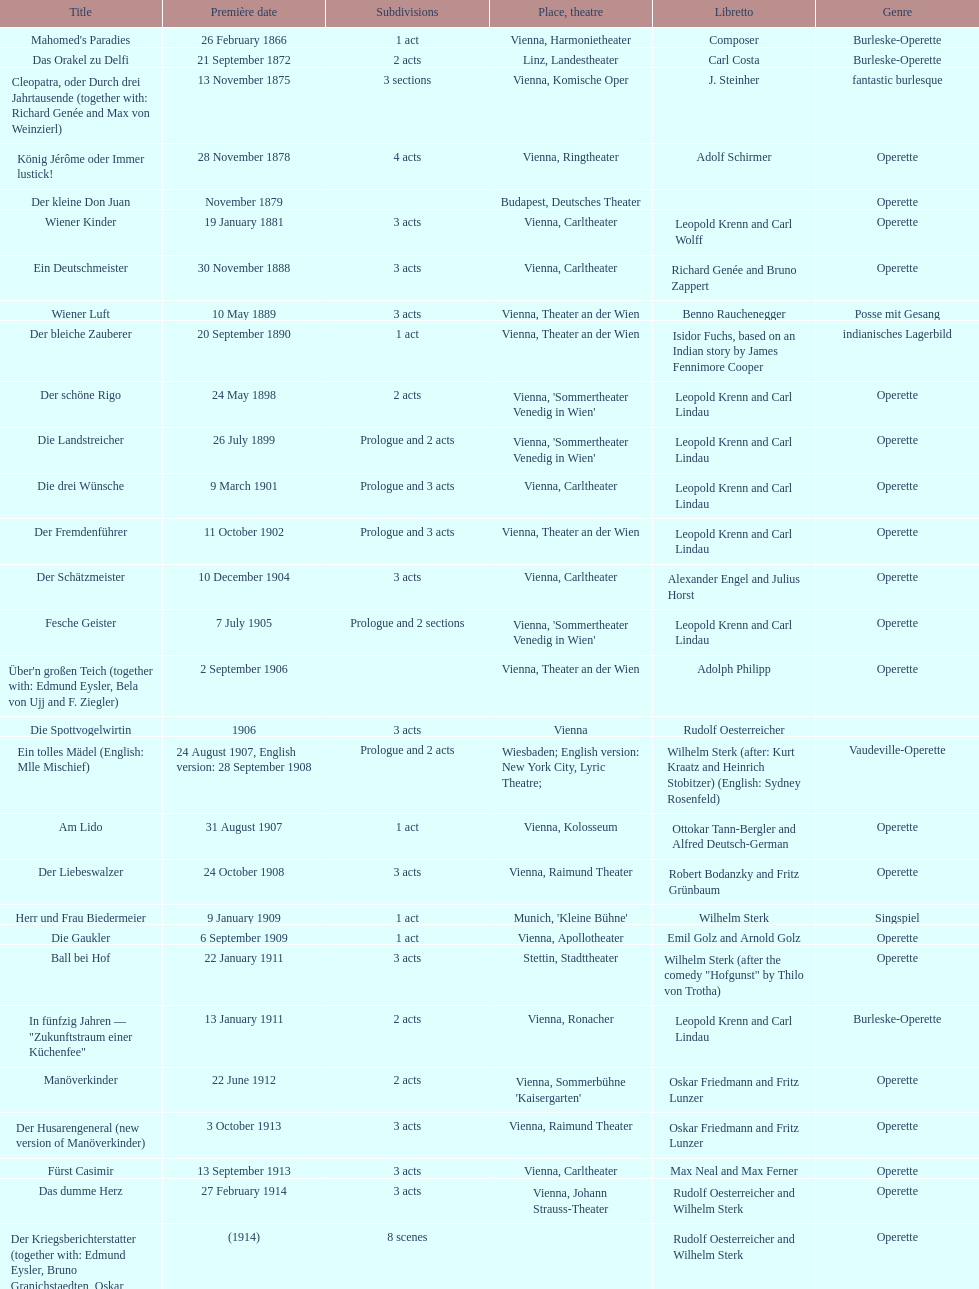All the dates are no later than what year? 1958. 